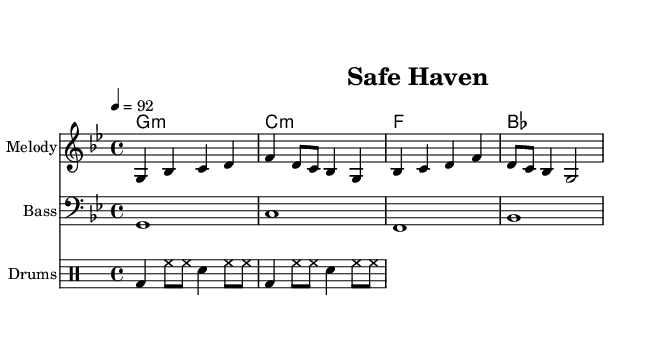What is the time signature of this music? The time signature is shown at the beginning of the music and indicates the meter. In this piece, it is written as 4/4, indicating four beats in a measure and a quarter note receives one beat.
Answer: 4/4 What is the key signature of this music? The key signature appears at the beginning of the music, identifying the scale for the piece. This music is in G minor, which has two flats: B and E.
Answer: G minor What is the tempo marking for this piece? The tempo marking is indicated at the beginning with "4 = 92," meaning the quarter note should be played at 92 beats per minute. This helps determine the overall speed of the music.
Answer: 92 How many measures are in the melody? To determine the number of measures, we count the distinct segments separated by bar lines in the melody section. There are four measures total in the provided melody.
Answer: 4 Which instrument plays the bass part? The bass part is indicated within a separate staff using a bass clef. This indicates the instrument that typically plays lower pitches, often a bass guitar or upright bass.
Answer: Bass What lyrical theme is expressed in this song? The lyrics express a theme of community and safety, emphasizing unity and resilience in the face of challenges. The phrase "Safe haven, our island home" suggests a focus on the importance of security in the community.
Answer: Community safety 